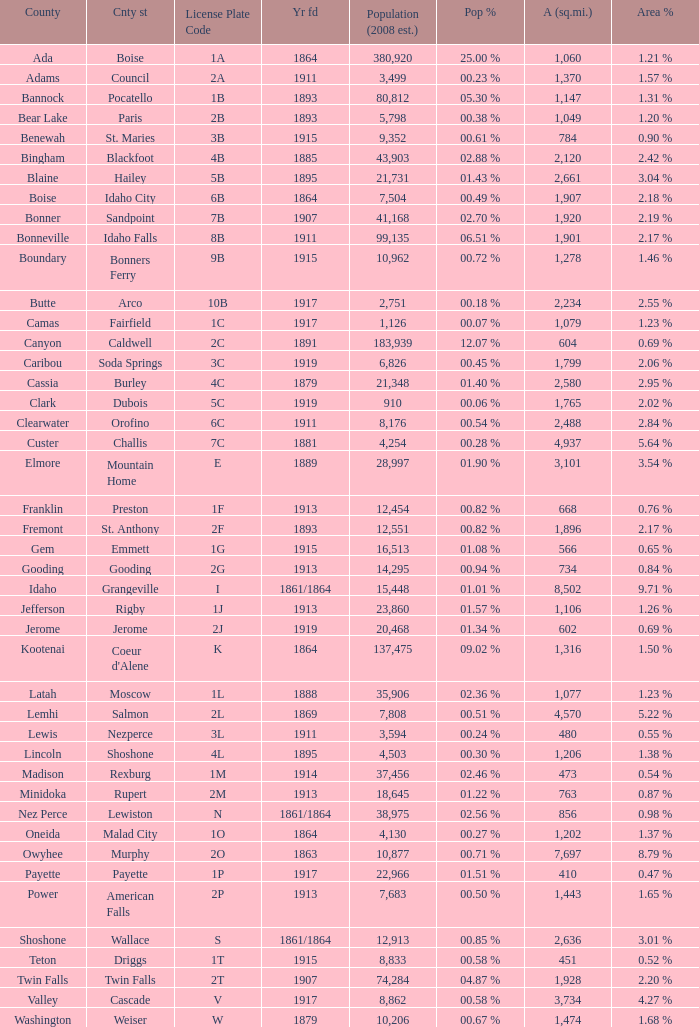What is the license plate code for the country with an area of 784? 3B. 